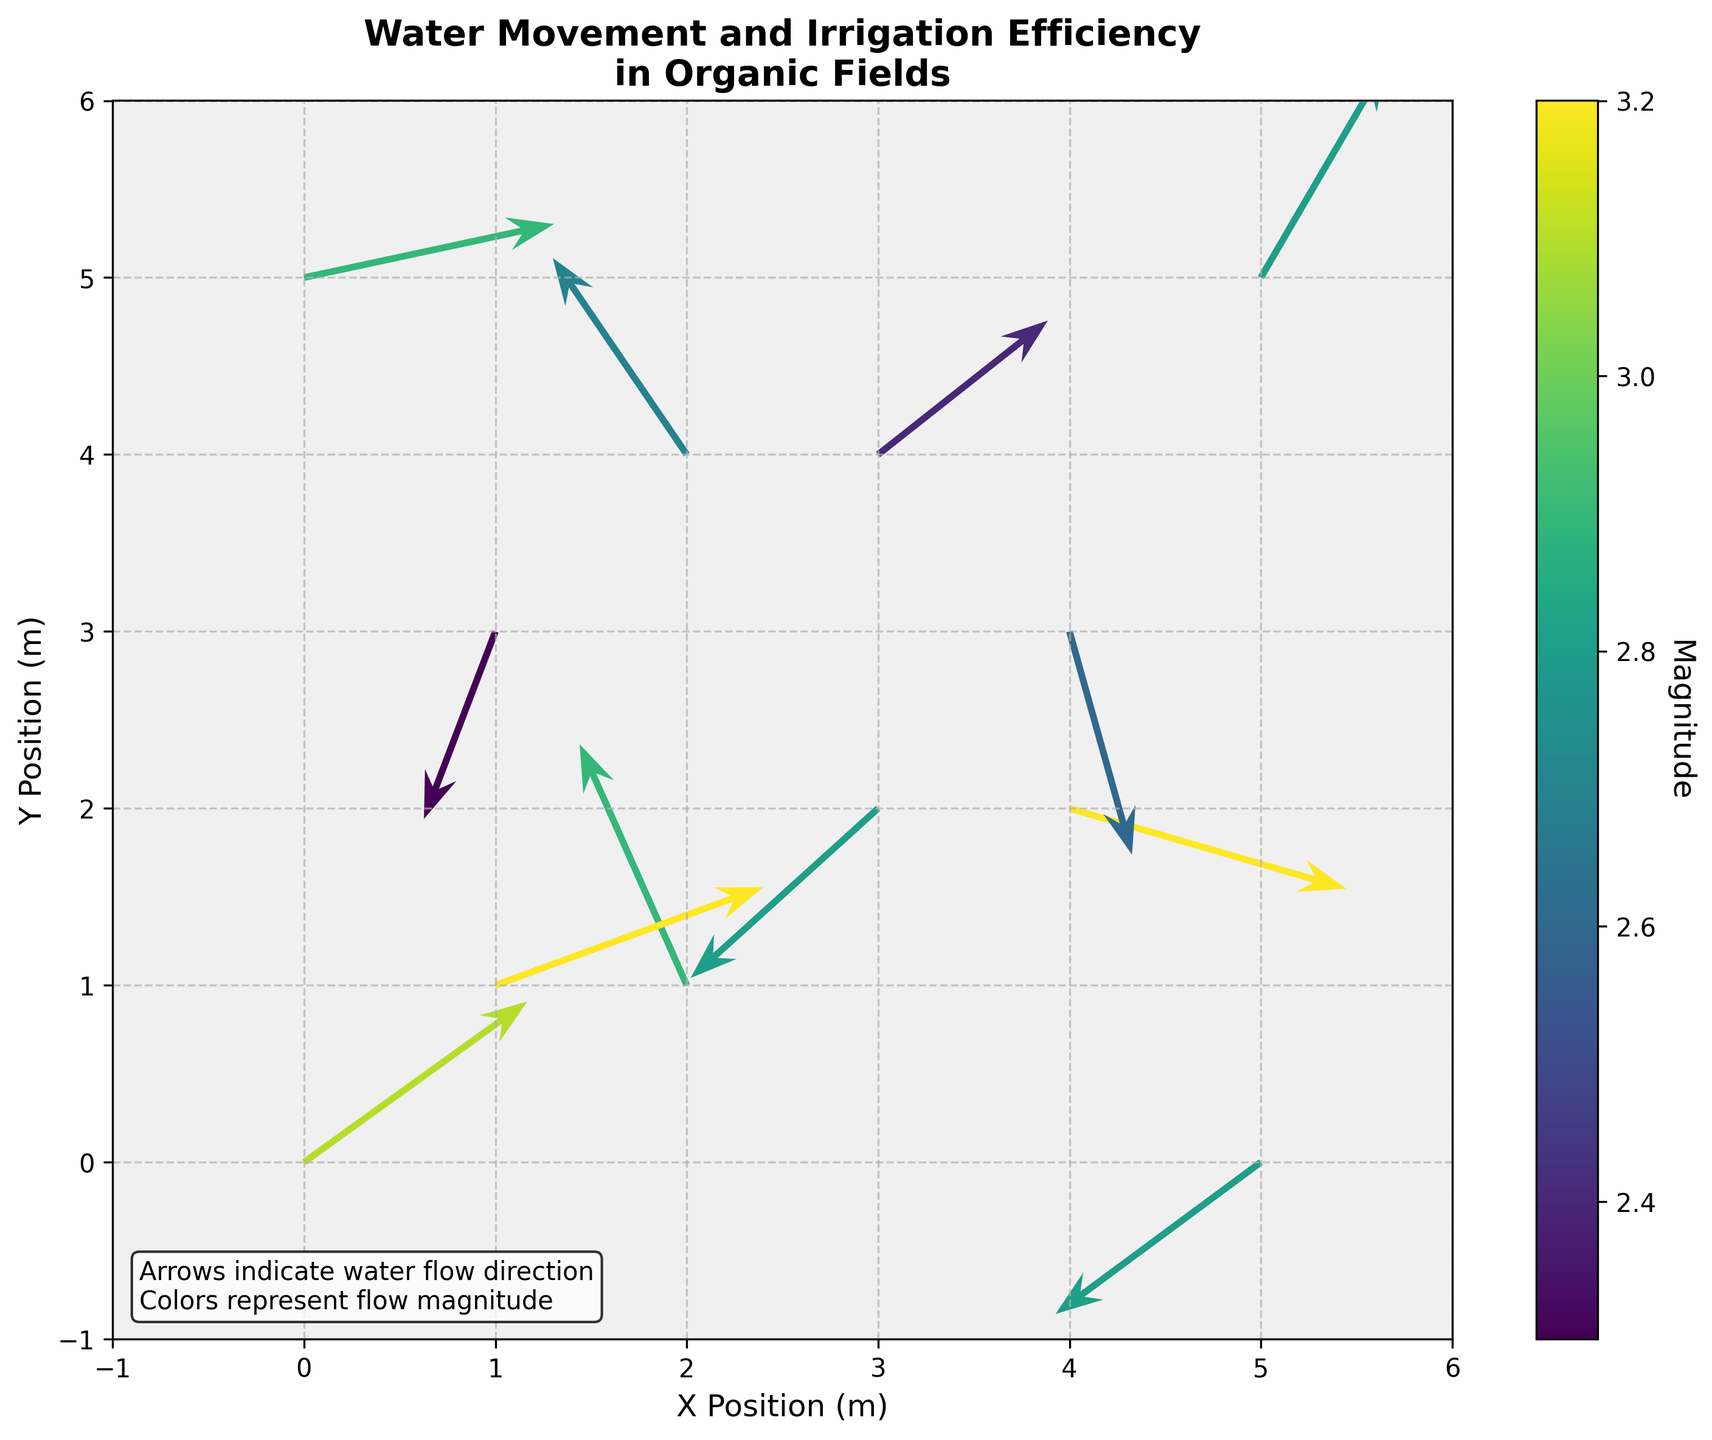What is the title of the plot? The title of the plot is always displayed prominently at the top of the figure. Looking at the plot, you can read the title directly.
Answer: Water Movement and Irrigation Efficiency in Organic Fields What are the units for the positions on the X and Y axes? The units for the positions on the X and Y axes can be inferred from the axis labels. The axis labels mention 'X Position (m)' and 'Y Position (m),' indicating that the units are meters.
Answer: meters How many arrows are drawn on the quiver plot? Count each arrow represented in the quiver plot. Each arrow is drawn at the coordinate points specified by the data.
Answer: 12 Which color represents the highest magnitude of water flow? Look at the colorbar and identify the color that corresponds to the highest value on the magnitude scale. The color close to 3.2 on the colorbar represents the highest magnitude.
Answer: The color around the darkest shade on the viridis color scale What direction is the water flowing at the coordinates (2, 1)? Check the arrow originating from the coordinates (2, 1). The arrow's direction indicates the direction of water flow, with the arrowhead pointing towards that direction.
Answer: The water is flowing towards the top left What is the range of water flow magnitude represented in the plot? The range of water flow magnitude can be found by looking at the colorbar, which shows the minimum and maximum magnitude values.
Answer: 2.3 to 3.2 Which arrow is the longest, and what are its coordinates and magnitude? The length of each arrow represents its magnitude. The longest arrow can be identified by visually inspecting the arrows or checking the data. The coordinates and magnitude of the longest arrow need to be noted.
Answer: The longest arrow is at (4, 2) with a magnitude of 3.2 Are there more arrows with negative U components or positive U components? To answer this, check the U values in the dataset, count the number of negative and positive U components, and compare the counts.
Answer: There are slightly more arrows with negative U components At which coordinate does the water flow mostly towards the bottom-right? Check the direction of the arrows and identify the one that points mainly towards the bottom-right direction.
Answer: The arrow at (0,0) flows mostly towards the bottom-right Which arrows exhibit both negative U and V components and what are their coordinates? Examine the dataset for arrows with both negative U and V components to find their coordinates.
Answer: Arrows at coordinates (1, 3) and (5, 0) What is the average magnitude of the water flow in the plot? To find the average magnitude, sum up all the magnitude values from the dataset and then divide by the number of arrows. Sum = 3.1 + 2.9 + 3.2 + 2.3 + 2.4 + 2.8 + 2.9 + 2.7 + 2.6 + 3.2 + 2.8 + 2.8 = 35.7; Average = 35.7 / 12
Answer: 2.975 